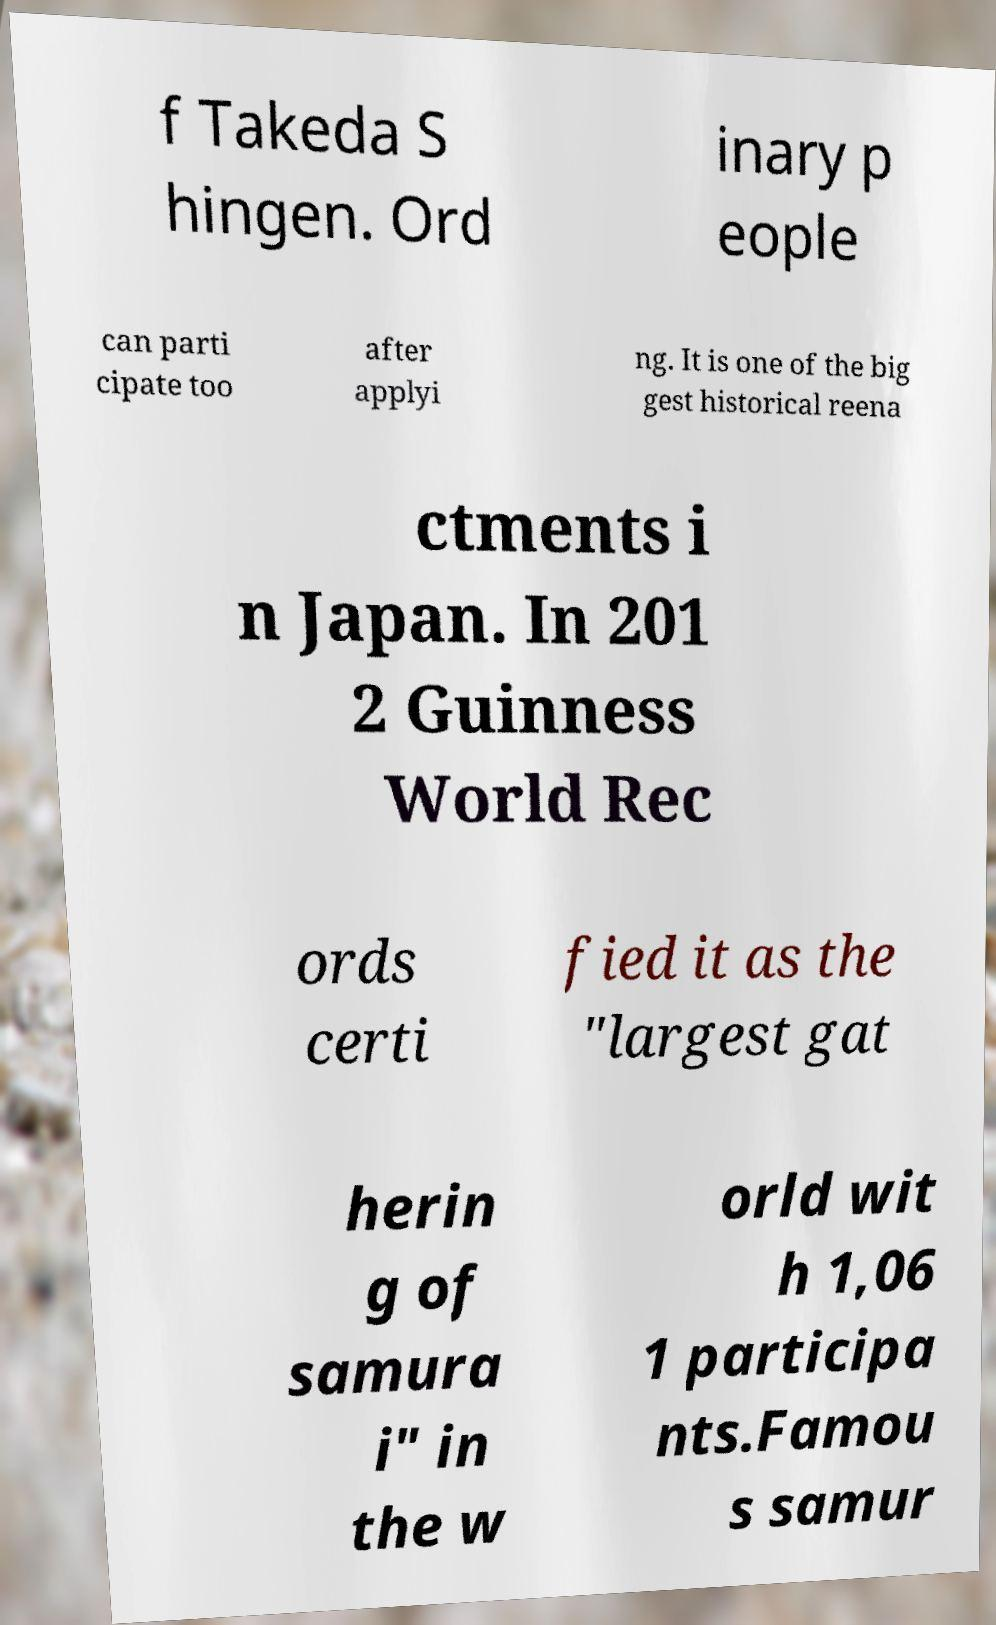Please identify and transcribe the text found in this image. f Takeda S hingen. Ord inary p eople can parti cipate too after applyi ng. It is one of the big gest historical reena ctments i n Japan. In 201 2 Guinness World Rec ords certi fied it as the "largest gat herin g of samura i" in the w orld wit h 1,06 1 participa nts.Famou s samur 